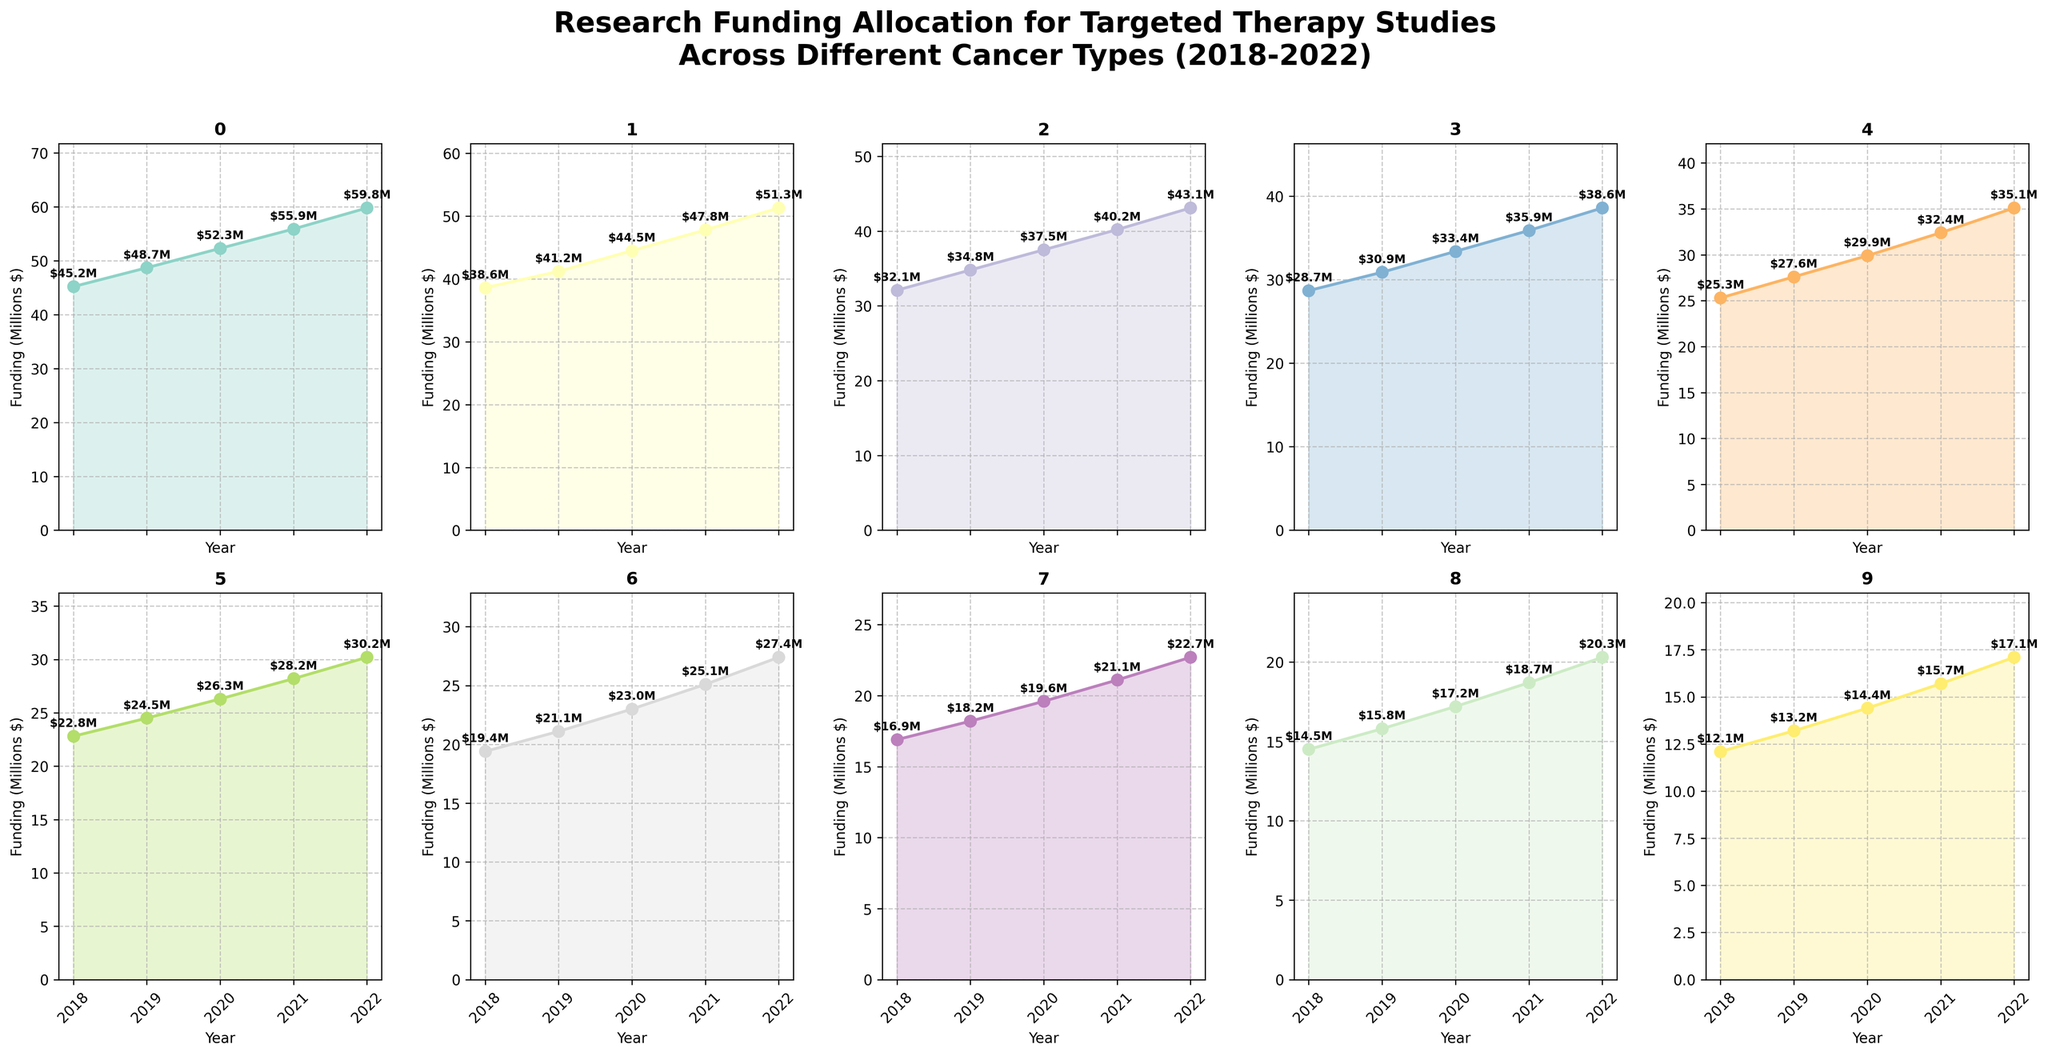What is the title of the figure? The title of the figure is found at the top and summarizes the entire content being shown in the subplots. The actual title states 'Research Funding Allocation for Targeted Therapy Studies Across Different Cancer Types (2018-2022)'.
Answer: Research Funding Allocation for Targeted Therapy Studies Across Different Cancer Types (2018-2022) Which cancer type had the highest research funding in 2022? By examining the last data point in each of the subplots, Breast Cancer shows the highest value at 59.8 million dollars in 2022.
Answer: Breast Cancer How did the research funding for Pancreatic Cancer change from 2018 to 2022? Observing the subplot for Pancreatic Cancer, the funding increased from 19.4 million dollars in 2018 to 27.4 million dollars in 2022.
Answer: Increased from 19.4M to 27.4M Which cancer type shows the smallest increase in funding from 2018 to 2022? Calculating the difference between the funding in 2022 and 2018 for each cancer type, Bladder Cancer has the smallest increase (17.1M - 12.1M = 5M).
Answer: Bladder Cancer What is the average funding for Lung Cancer over the five years? Sum all the funding values for Lung Cancer over 2018 to 2022 (38.6+41.2+44.5+47.8+51.3=223.4) and divide by the number of years (5) to get the average: 223.4/5.
Answer: 44.68M In which year did Colorectal Cancer receive the highest amount of funding? The highest funding point for Colorectal Cancer subplot occurs in 2022, with a value of 43.1 million dollars.
Answer: 2022 Compare the total funding for Breast Cancer and Liver Cancer in 2021. Which one is greater and by how much? Sum the funding values for Breast and Liver Cancer in 2021 (55.9M for Breast and 18.7M for Liver). Subtract the lesser value from the greater year: 55.9 - 18.7 = 37.2M.
Answer: Breast Cancer by 37.2M How many cancer types had a funding of over 20 million dollars in 2019? Identify the 2019 funding values in each subplot. There are Breast, Lung, Colorectal, Prostate, Melanoma, and Leukemia with above 20M in 2019.
Answer: 6 Is the trend of funding increasing, decreasing, or stable for Ovarian Cancer between 2018 and 2022? Observing the subplot for Ovarian Cancer, the funding consistently increases from 16.9M in 2018 to 22.7M in 2022 without any declines.
Answer: Increasing Which cancer type had a funding amount closest to 30 million dollars in 2022? By comparing the 2022 values in each subplot, Leukemia had a funding of 30.2 million dollars, which is the closest to 30 million.
Answer: Leukemia 